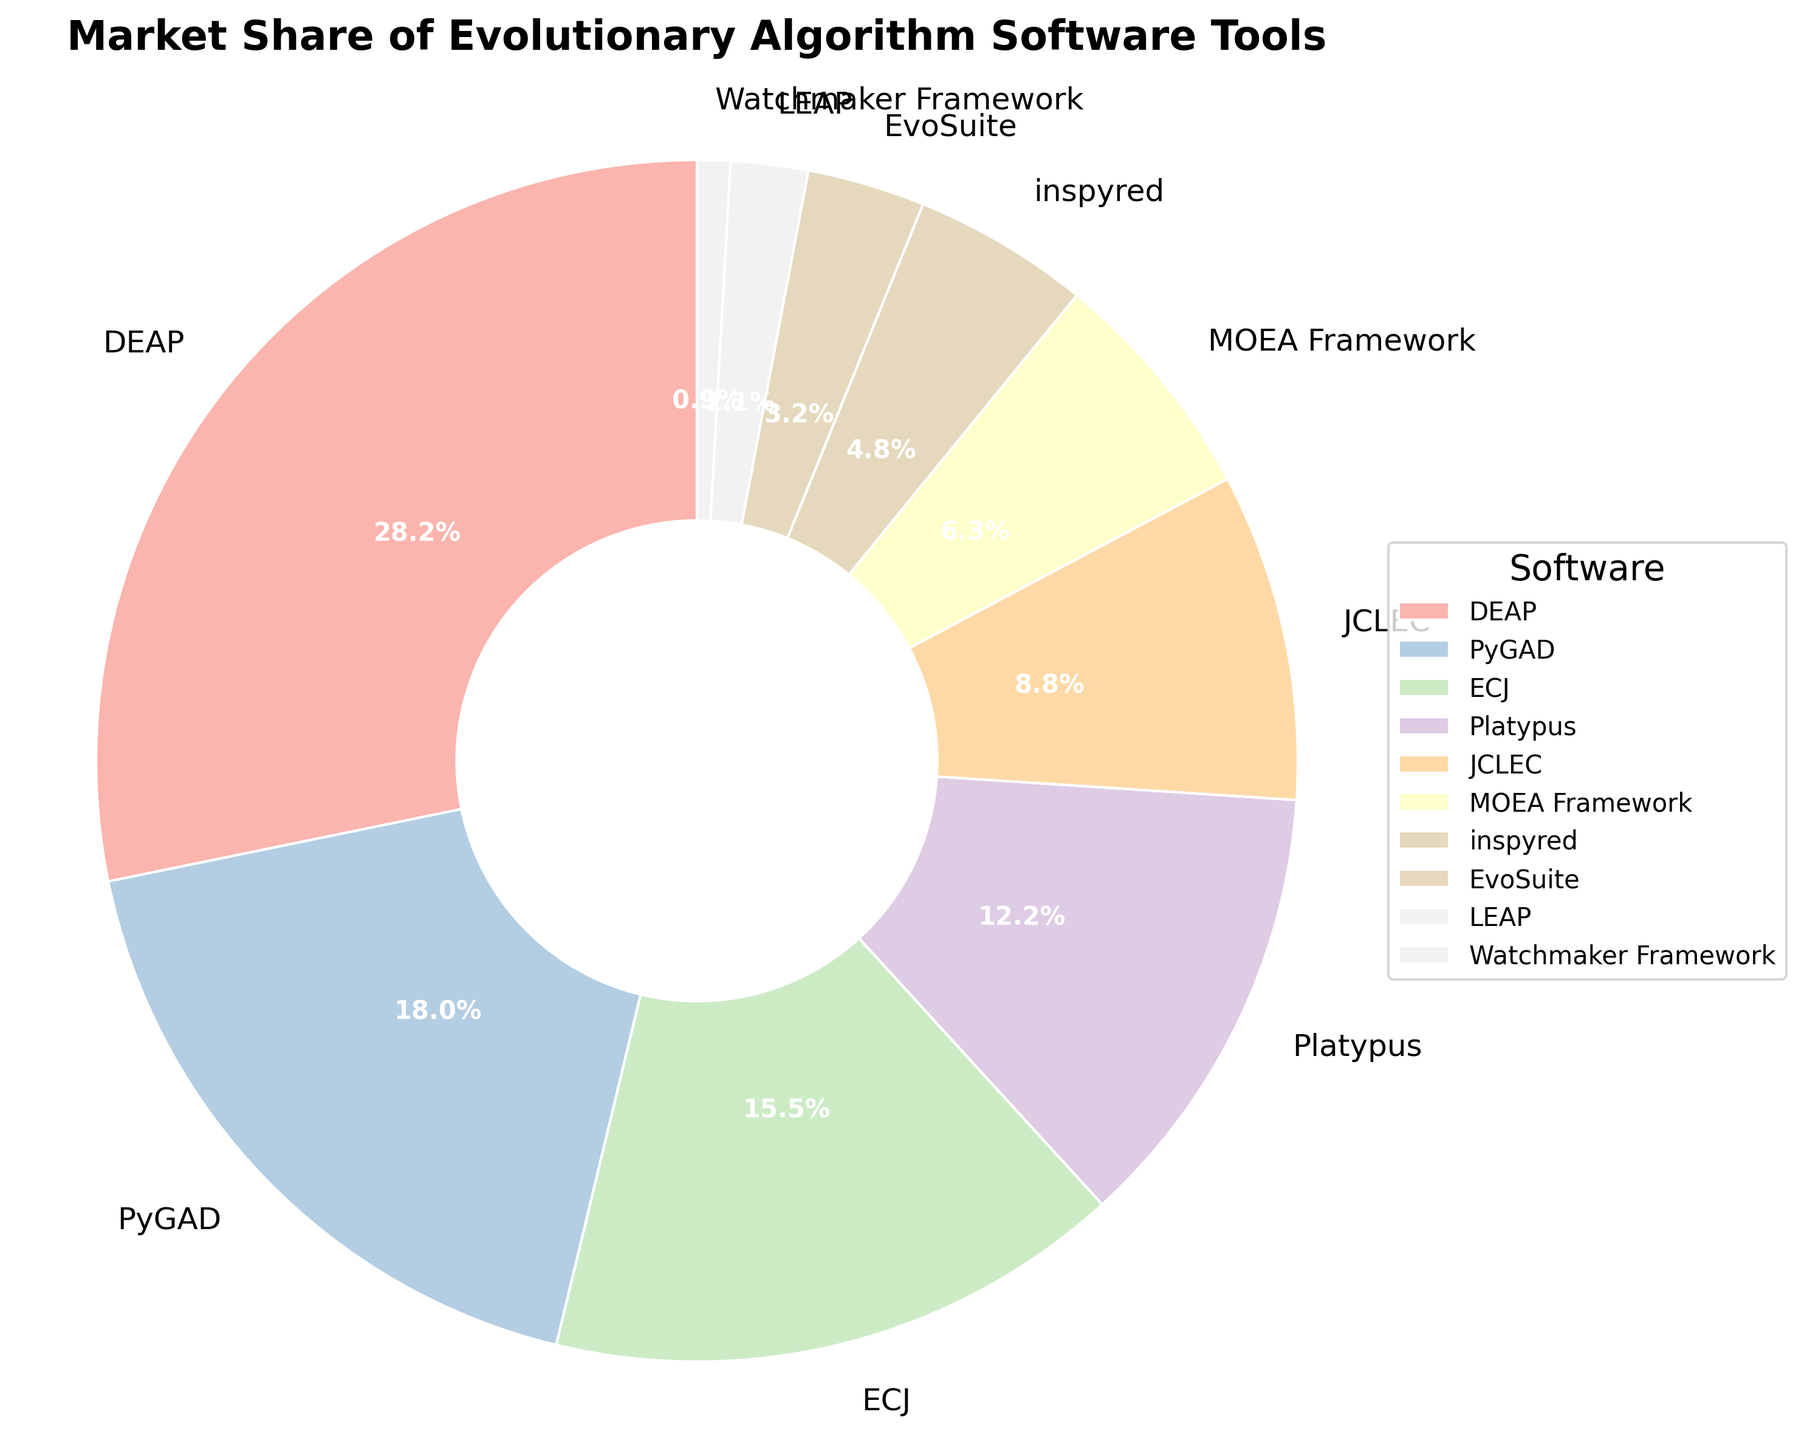Which software has the highest market share? Look for the software with the largest slice in the pie chart. DEAP has the largest slice with 28.5%.
Answer: DEAP Which software has the smallest market share? Look for the software with the smallest slice in the pie chart. Watchmaker Framework has the smallest slice with 0.9%.
Answer: Watchmaker Framework What is the total market share of DEAP and PyGAD combined? Sum the market shares of DEAP (28.5%) and PyGAD (18.2%). 28.5 + 18.2 = 46.7%.
Answer: 46.7% Is ECJ's market share greater than the combined market share of inspyred and EvoSuite? Compare ECJ's 15.7% with the sum of inspyred (4.8%) and EvoSuite (3.2%). 4.8 + 3.2 = 8.0%. 15.7% > 8.0%
Answer: Yes How many software tools have a market share greater than or equal to 12%? Count the number of slices that have a market share of at least 12%. DEAP (28.5%), PyGAD (18.2%), ECJ (15.7%), and Platypus (12.3%) make up 4 tools.
Answer: 4 What is the difference in market share between JCLEC and MOEA Framework? Subtract MOEA Framework's market share (6.4%) from JCLEC's market share (8.9%). 8.9 - 6.4 = 2.5%.
Answer: 2.5% Which software tool has a market share closest to 10%? Identify the slice whose market share is nearest to 10%. Platypus has a market share of 12.3%, which is closest to 10%.
Answer: Platypus What fraction of the total market share is represented by LEAP and Watchmaker Framework together? Sum the market shares of LEAP (2.1%) and Watchmaker Framework (0.9%). 2.1 + 0.9 = 3%. The total market share is 100%, so the fraction is 3%.
Answer: 3% How does the market share of PyGAD compare to the combined market share of JCLEC and MOEA Framework? Compare PyGAD's market share (18.2%) with the sum of JCLEC (8.9%) and MOEA Framework (6.4%). 8.9 + 6.4 = 15.3%. 18.2% > 15.3%
Answer: PyGAD has a greater market share If the software with the least market share disappeared, what would be the new total percentage of the remaining software? Subtract the market share of the Watchmaker Framework (0.9%) from 100%. 100 - 0.9 = 99.1%.
Answer: 99.1% 